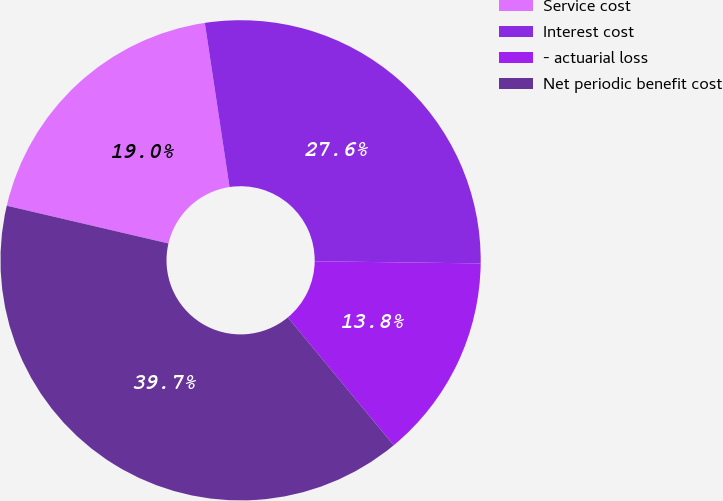<chart> <loc_0><loc_0><loc_500><loc_500><pie_chart><fcel>Service cost<fcel>Interest cost<fcel>- actuarial loss<fcel>Net periodic benefit cost<nl><fcel>18.97%<fcel>27.59%<fcel>13.79%<fcel>39.66%<nl></chart> 